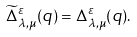<formula> <loc_0><loc_0><loc_500><loc_500>\widetilde { \Delta } ^ { \varepsilon } _ { \lambda , \mu } ( q ) = \Delta ^ { \varepsilon } _ { \lambda , \mu } ( q ) .</formula> 